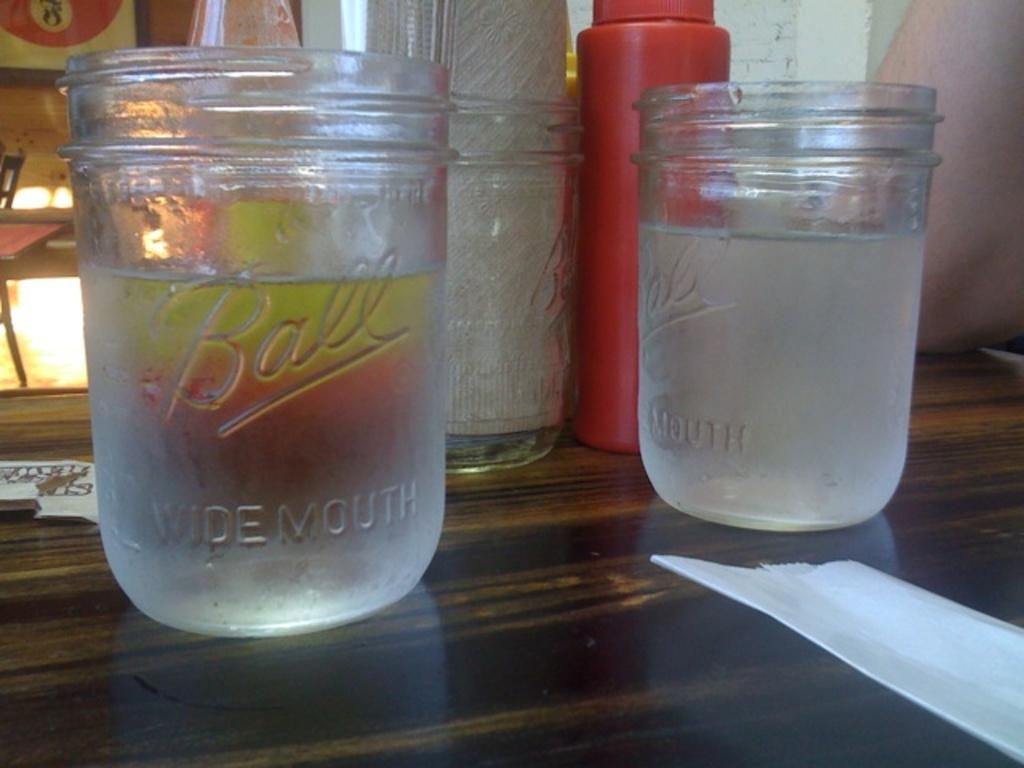<image>
Summarize the visual content of the image. Two clear Ball Widemouth glasses sitting on a table 